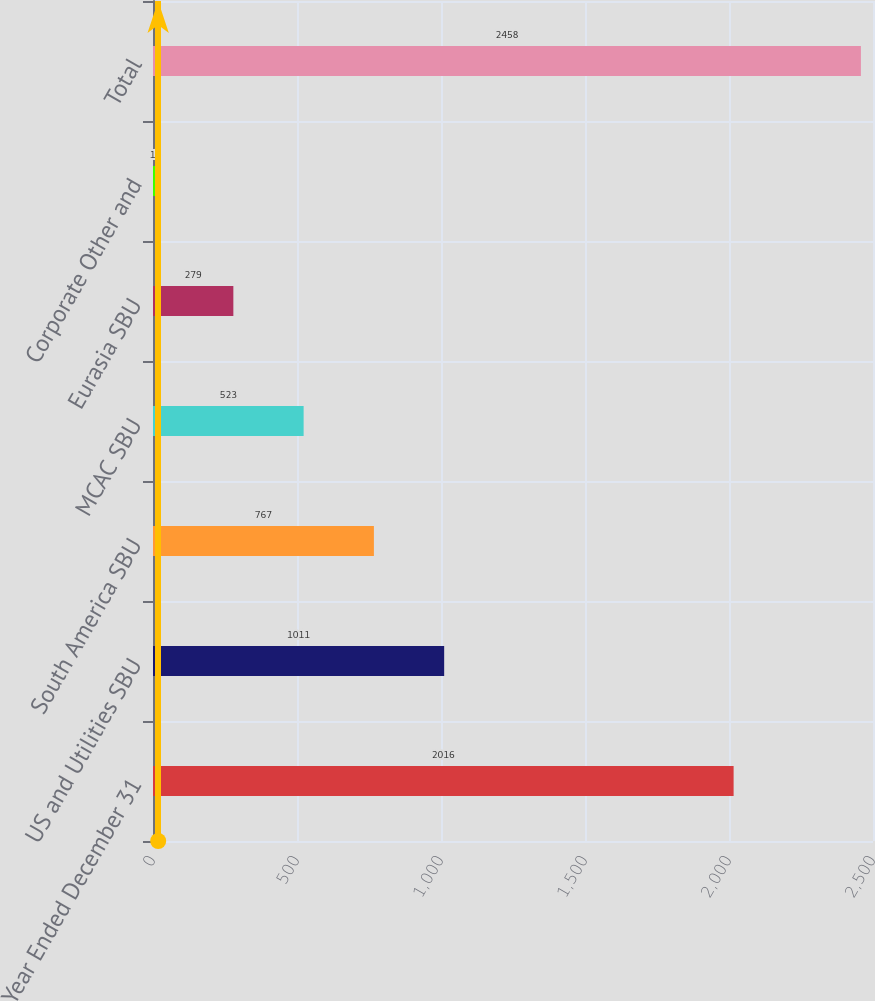Convert chart. <chart><loc_0><loc_0><loc_500><loc_500><bar_chart><fcel>Year Ended December 31<fcel>US and Utilities SBU<fcel>South America SBU<fcel>MCAC SBU<fcel>Eurasia SBU<fcel>Corporate Other and<fcel>Total<nl><fcel>2016<fcel>1011<fcel>767<fcel>523<fcel>279<fcel>18<fcel>2458<nl></chart> 